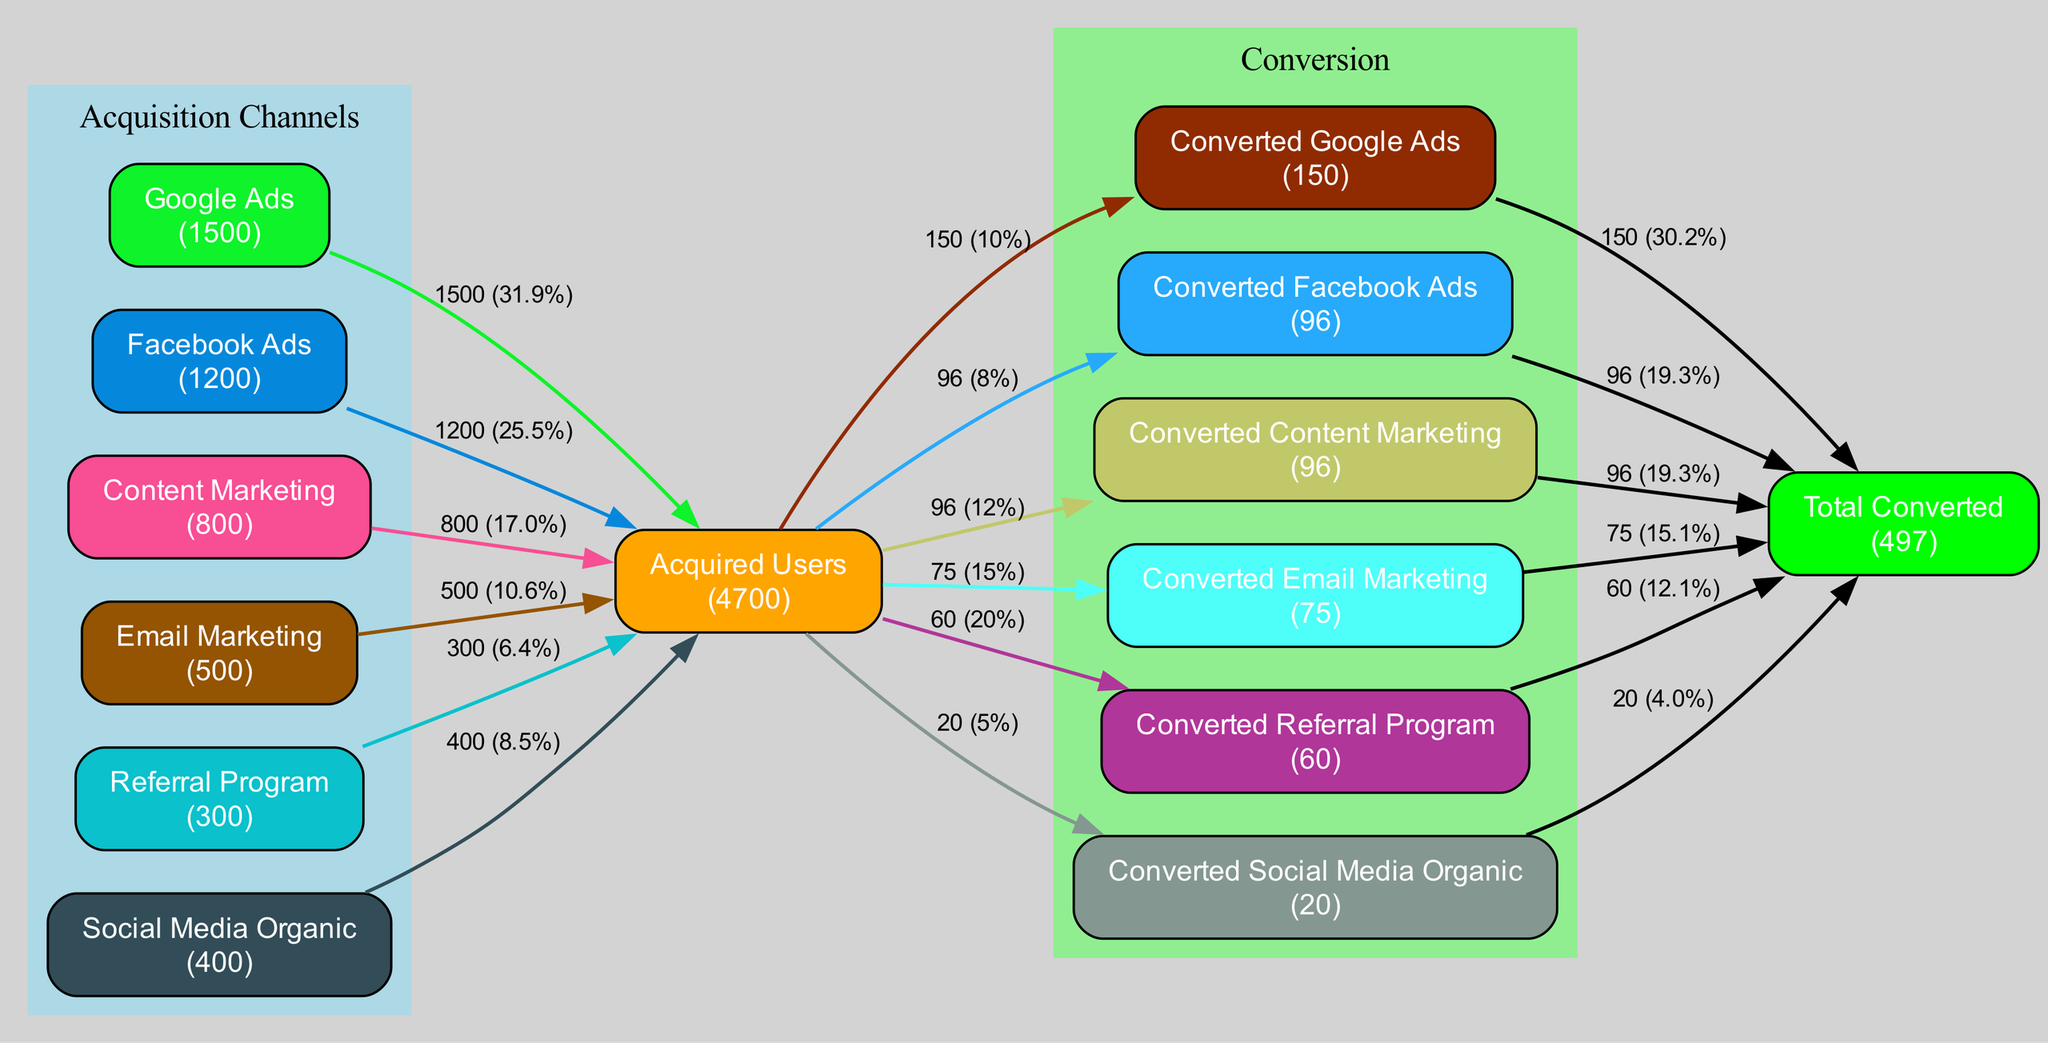What is the total user acquisition from Google Ads? According to the diagram, Google Ads has an acquisition value of 1500 users, which is depicted in the node representing this channel.
Answer: 1500 How many total users were acquired across all channels? The diagram summarizes the total acquisitions as the total of all user acquisitions from each channel, which is calculated to be 1500 + 1200 + 800 + 500 + 300 + 400 = 3900 users. This total is indicated in the node labeled "Acquired Users."
Answer: 3900 What is the conversion rate for Email Marketing? The diagram shows Email Marketing has a conversion rate of 15%, which is noted in the corresponding edge connecting "Acquired Users" to "Converted Email Marketing."
Answer: 15% Which channel has the highest conversion count? To determine this, we can look at the conversion counts for each channel: Google Ads has 150, Facebook Ads 96, Content Marketing 96, Email Marketing 75, Referral Program 60, and Social Media Organic 20. The highest conversion count is from Google Ads at 150 users.
Answer: Google Ads How many users converted from the Referral Program? From the diagram, the edge leading to "Converted Referral Program" shows that 60 users converted from this channel.
Answer: 60 What percentage of total conversions came from Facebook Ads? The total conversions sum up to 150 + 96 + 96 + 75 + 60 + 20 = 497. The conversions from Facebook Ads are 96. The percentage can be calculated as (96 / 497) * 100, which approximately equals 19.3%. This information is reflected in the edge connecting "Converted Facebook Ads" to "Total Converted."
Answer: 19.3% Which channel had the lowest user acquisition? By analyzing the acquisition numbers, the lowest acquisition is found in the Referral Program, which had 300 users acquired. This is stated in the node for that channel.
Answer: Referral Program What is the total conversion rate across all channels? To find the total conversion rate, we need to divide the total conversions (497) by total acquisitions (3900) and multiply by 100. Thus, the total conversion rate is (497 / 3900) * 100, which yields approximately 12.7%. This is inferred from the total nodes and edges.
Answer: 12.7% 